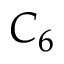Convert formula to latex. <formula><loc_0><loc_0><loc_500><loc_500>C _ { 6 }</formula> 